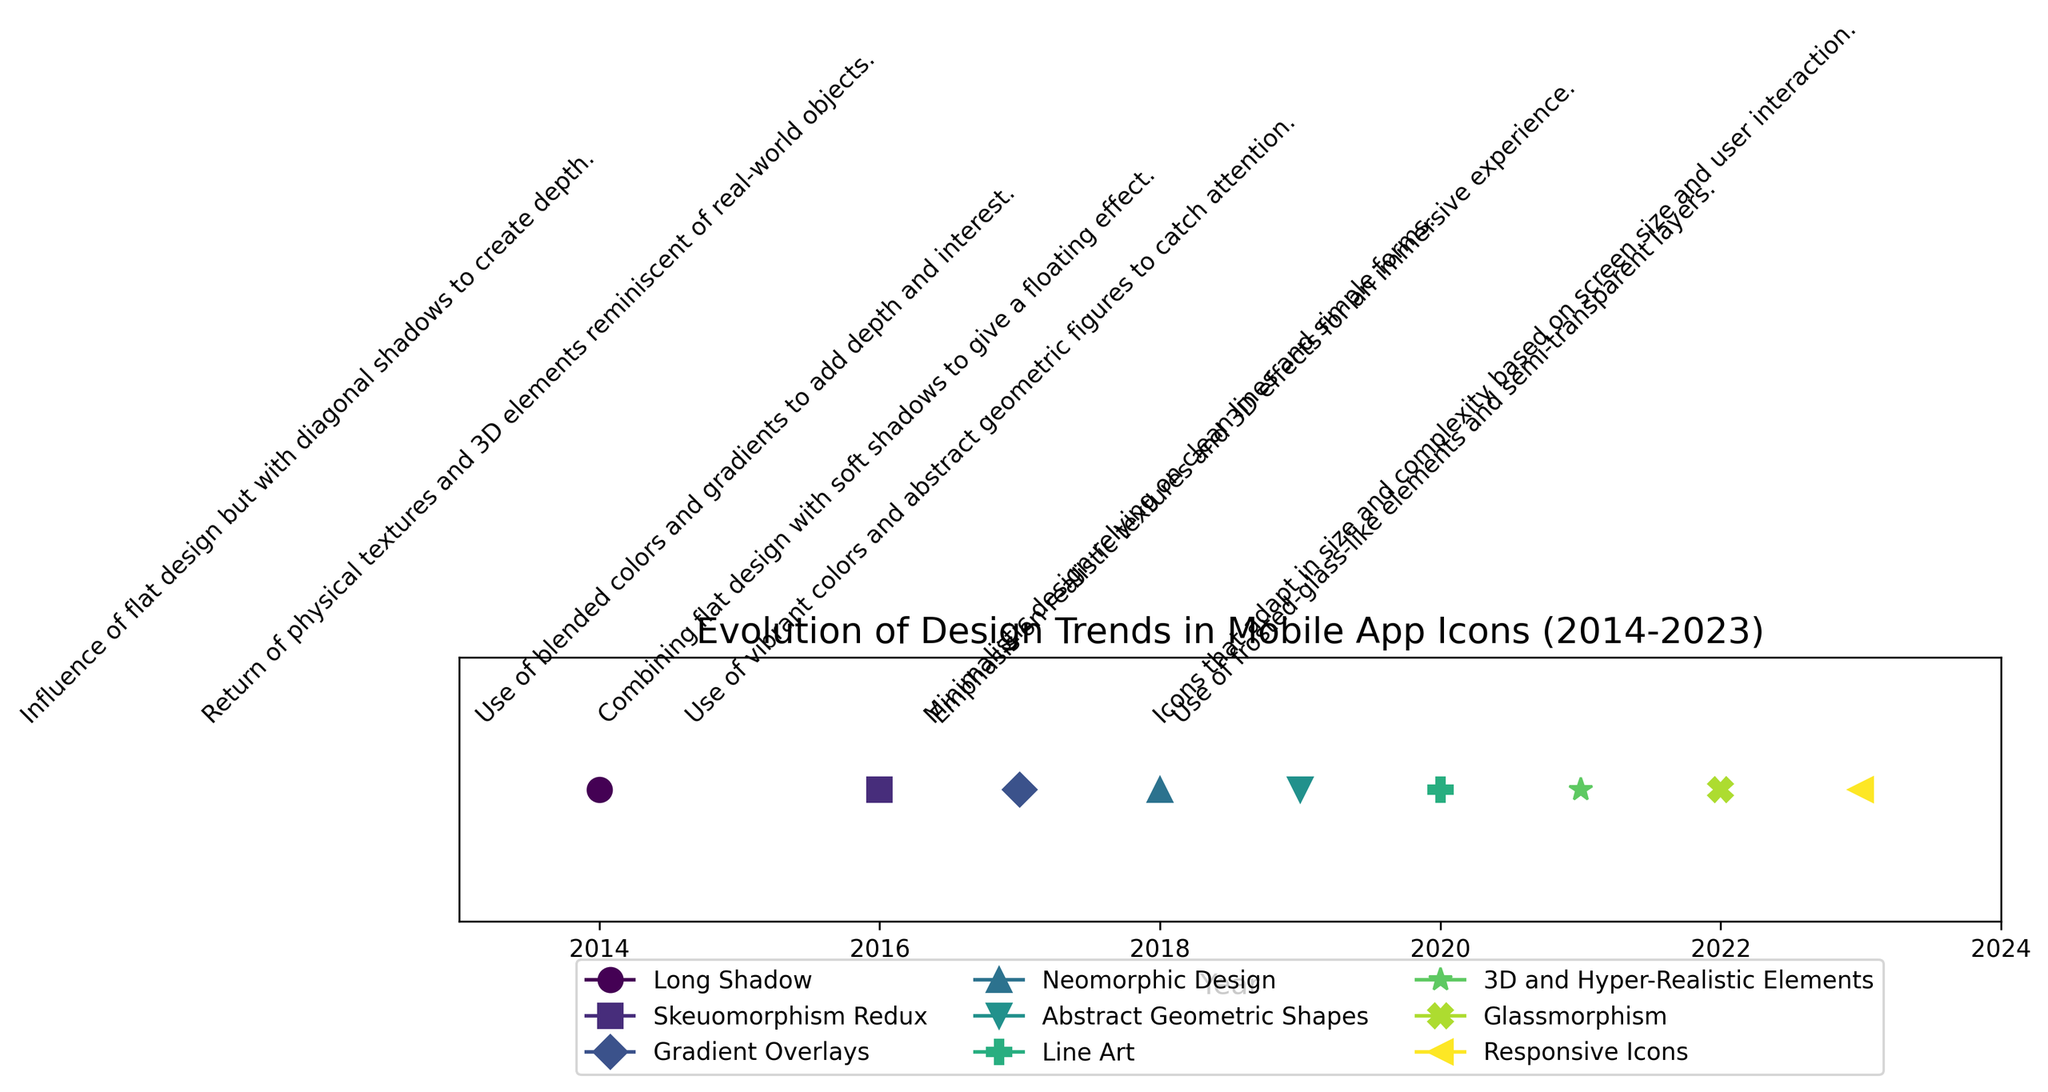What is the design trend for the year 2020? Look at the marker labelled as 2020 on the x-axis. It is associated with the design trend "Line Art."
Answer: Line Art Which design trend has a text description rotated 45 degrees, and what is that description? Look at the angle of the text labels for each design trend. All descriptions are rotated 45 degrees. Pick any year to answer. For example, in 2014, the design trend "Long Shadow" has the description "Influence of flat design but with diagonal shadows to create depth.”
Answer: Influence of flat design but with diagonal shadows to create depth Between which two years did the trend "Gradient Overlays" appear? Find the point labeled "Gradient Overlays" and note its x-axis position, which indicates the year. Then check the years on either side of it. "Gradient Overlays" appears in 2017, so the years are 2016 and 2018.
Answer: 2016 and 2018 What is the general trend in design elements moving from 2014 to 2023? Observe the descriptions from early years to recent years. Initially, the trends like "Long Shadow" and "Skeuomorphism Redux" focused on depth and 3D elements. Recent trends like "3D and Hyper-Realistic Elements" and "Glassmorphism" emphasize realistic textures and semi-transparent layers. There has been a shift from flat design with shadows to more intricate and realistic graphics.
Answer: From flat design to realistic graphics How many distinct markers are used to represent the design trends? Examine the plot and count the different marker shapes used to represent each year. There are 9 different markers ( 'o', 's', 'D', '^', 'v', 'P', '*', 'X', '<').
Answer: 9 How does the design trend of 2018 differ visually from the design trend of 2016? Identify the markers for 2016 and 2018 on the plot. "Skeuomorphism Redux" in 2016 uses textures and 3D elements to mimic real-world objects, while "Neomorphic Design" in 2018 combines flat design with soft shadows to give a floating effect. The descriptors highlight their visual difference.
Answer: 2016 uses 3D elements; 2018 uses soft shadows Which design trend focuses on minimalistic design relying on clean lines and simple forms? Look at the description words for different years and find the one mentioning minimalistic design with clean lines. "Line Art" in 2020 matches this description.
Answer: Line Art In which year did the design trend emphasize abstract geometric shapes with vibrant colors? Locate the description mentioning abstract geometric shapes and vibrant colors. This corresponds to 2019.
Answer: 2019 What is the description associated with the 2023 design trend? Identify the marker for 2023 and read the text associated with it. The description states: "Icons that adapt in size and complexity based on screen size and user interaction."
Answer: Icons that adapt in size and complexity based on screen size and user interaction 